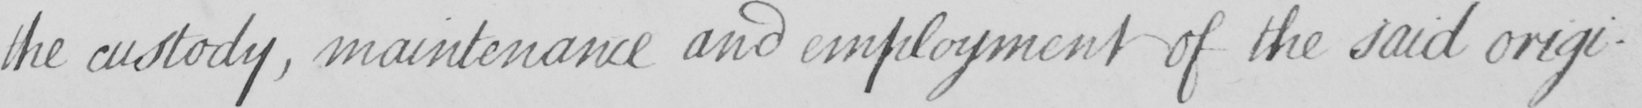Please transcribe the handwritten text in this image. the custody , maintenance and employment of the said origi- 